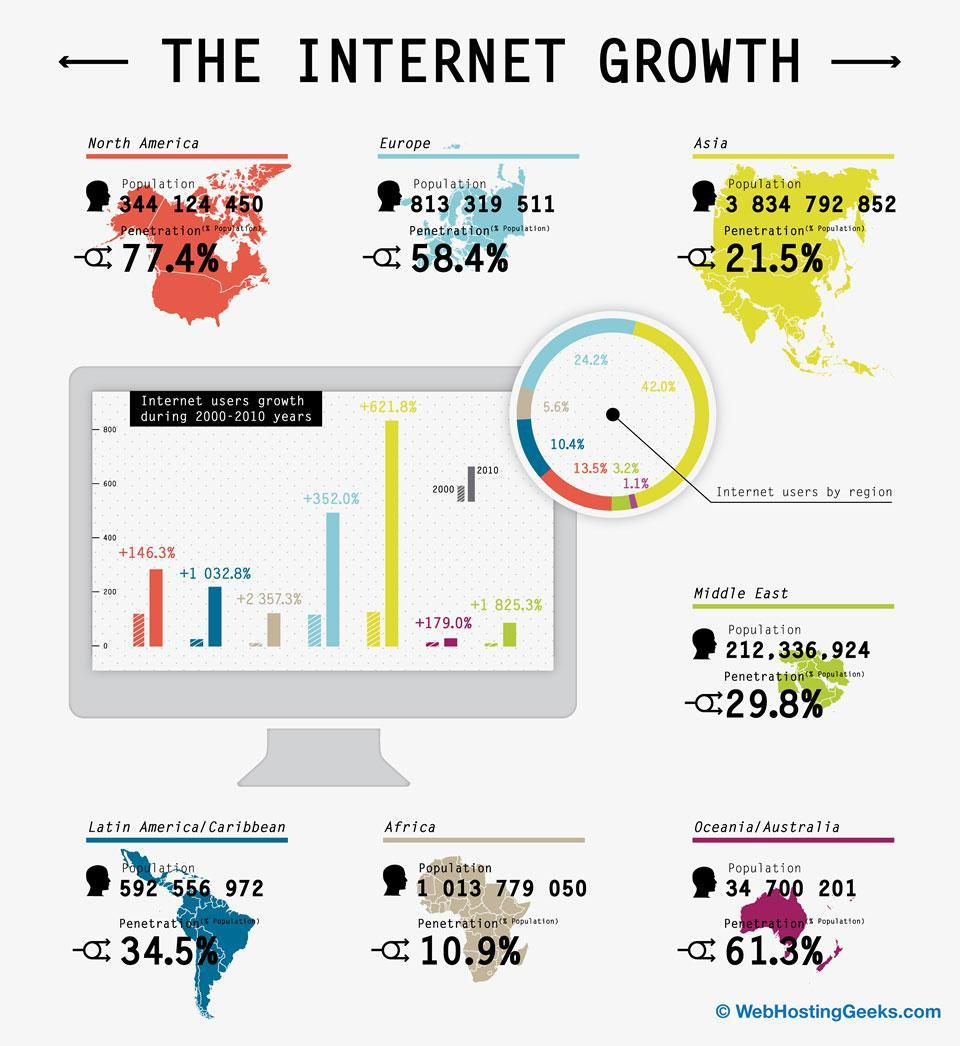By what percent is North America ahead of Europe in terms of penetration?
Answer the question with a short phrase. 19% 